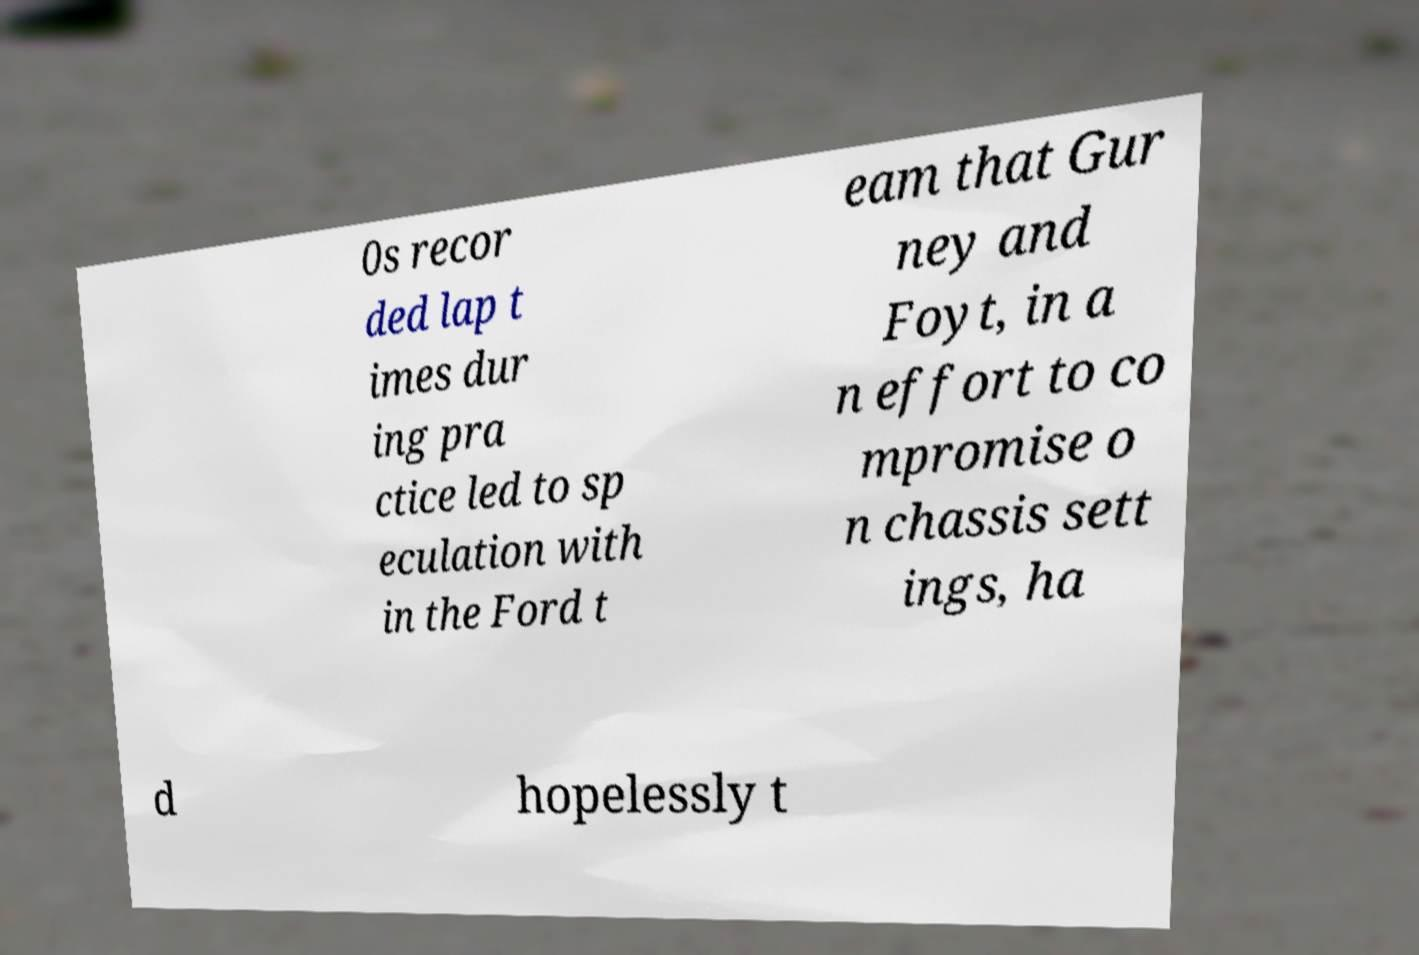Could you assist in decoding the text presented in this image and type it out clearly? 0s recor ded lap t imes dur ing pra ctice led to sp eculation with in the Ford t eam that Gur ney and Foyt, in a n effort to co mpromise o n chassis sett ings, ha d hopelessly t 